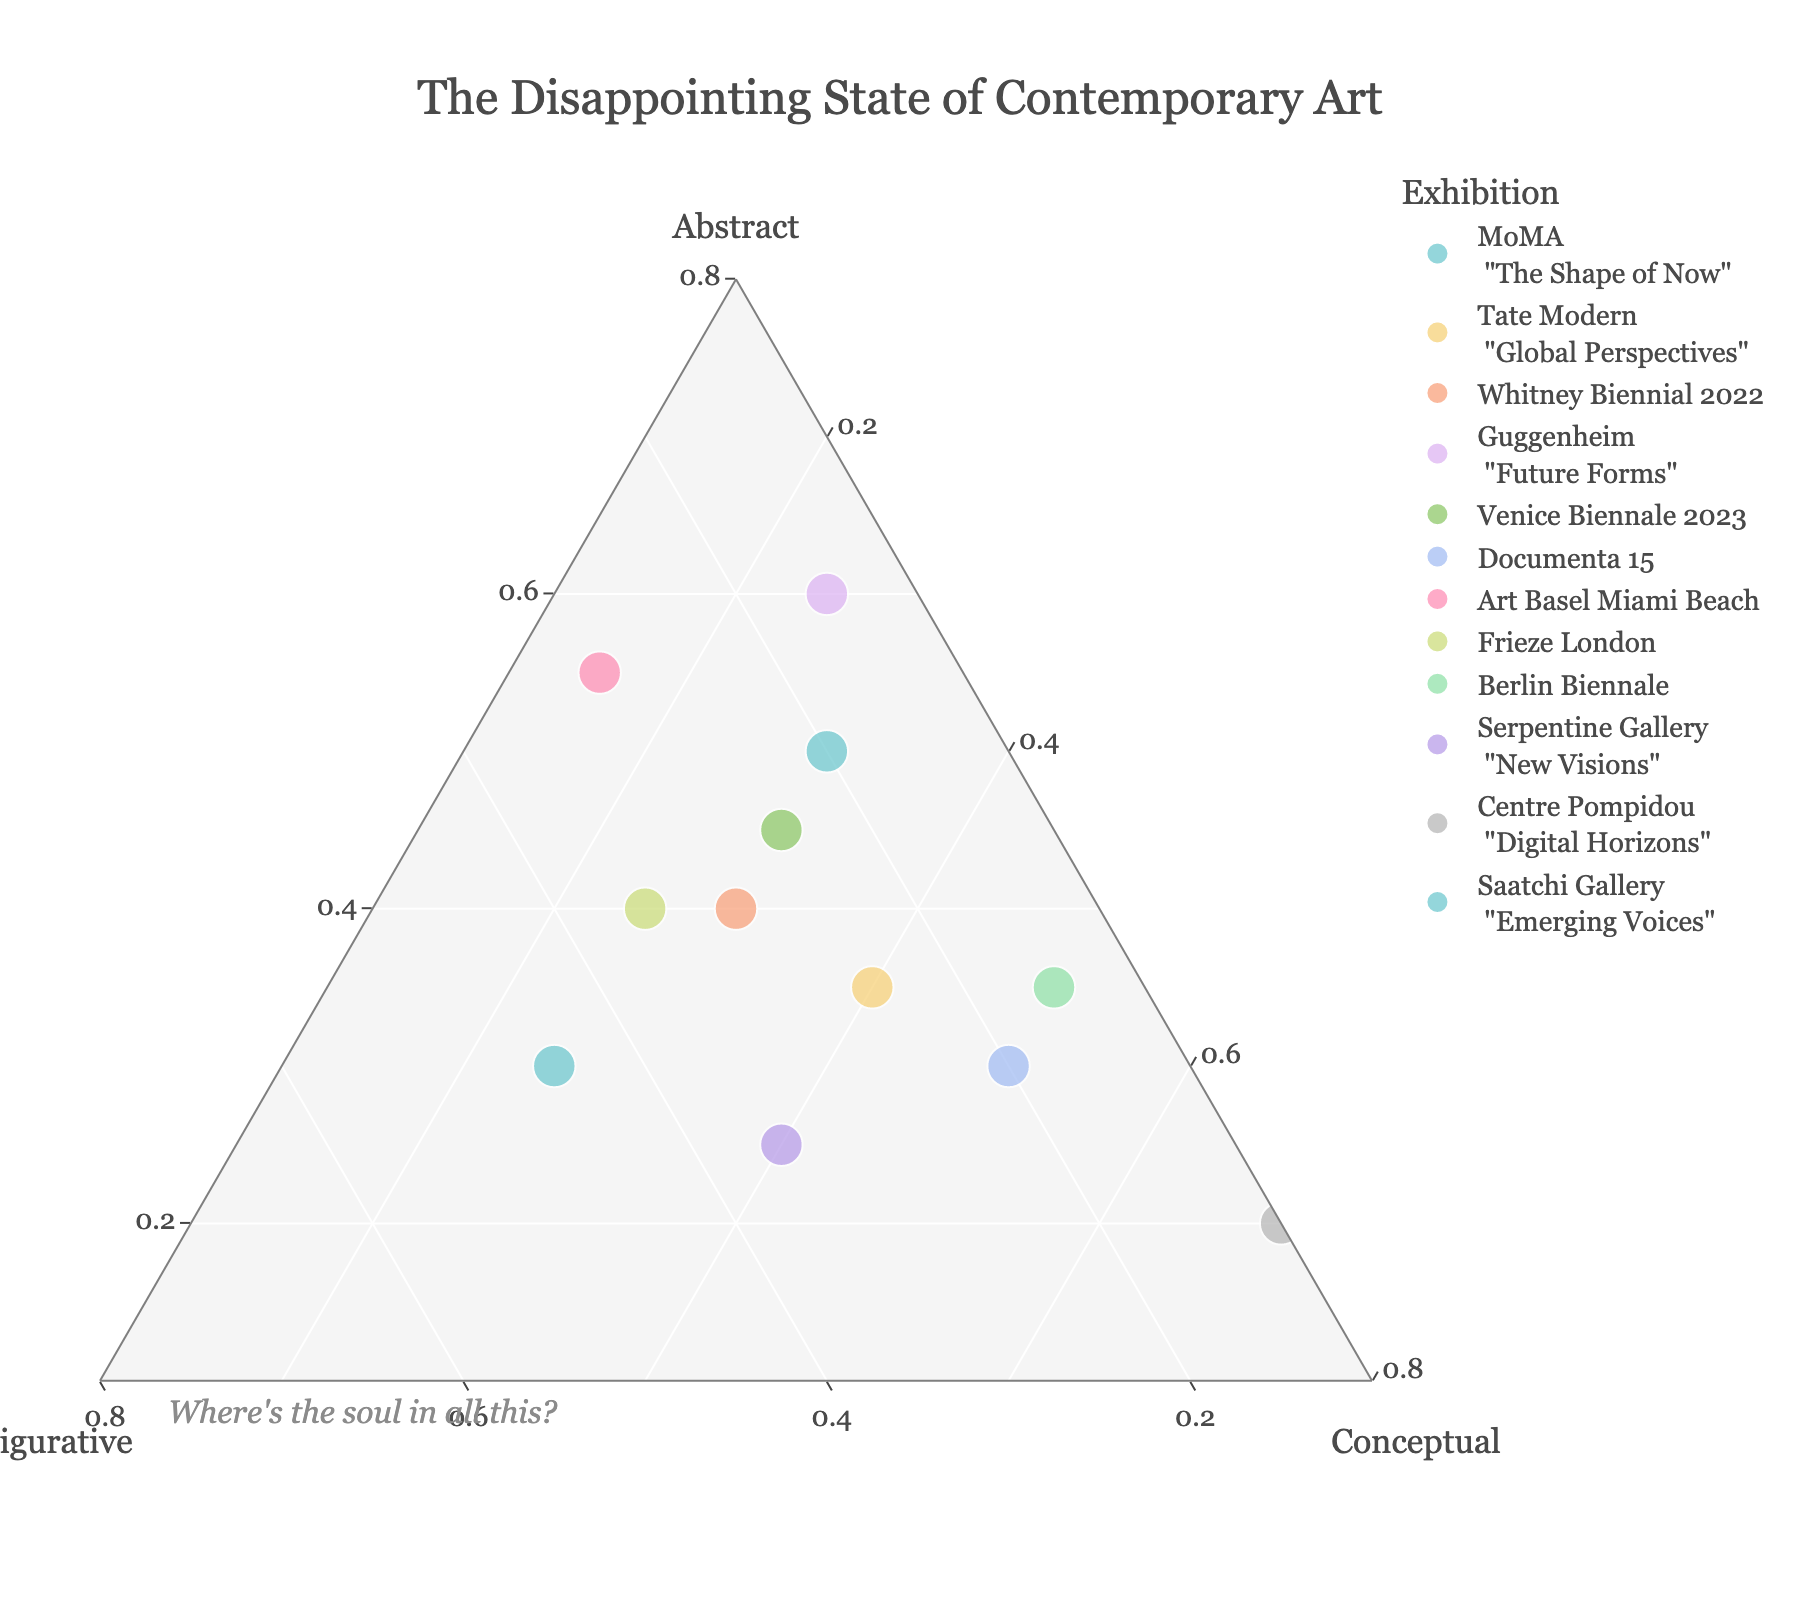What's the title of the figure? The title of the figure is positioned at the top of the plot and is often in a larger or bold font to distinguish it from other text.
Answer: The Disappointing State of Contemporary Art What are the three axes labeled in the figure? Ternary plots use three axes to represent three variables. These axis titles are typically positioned along the edges of the triangle.
Answer: Abstract, Figurative, Conceptual How many data points (exhibitions) are displayed in the figure? By counting the individual markers or points displayed within the ternary plot area, we can determine the total number of data points.
Answer: 12 Which exhibition has the highest percentage of conceptual art? To find this, you need to look at the markers located closest to the 'Conceptual' axis end within the ternary plot.
Answer: Centre Pompidou's <br> Digital Horizons Which exhibitions have an equal proportion of abstract and conceptual art? Identifying this requires finding points where the 'Abstract' and 'Conceptual' values are the same by checking their positions within the plot.
Answer: Venice Biennale 2023; Whitney Biennial 2022 What's the average percentage of abstract art across all exhibitions? Sum all the values of 'Abstract' percentages and divide by the number of exhibitions. Calculation: (50+35+40+60+45+30+55+40+35+25+20+30)/12 = 38.75
Answer: 38.75 In which exhibition is the figurative art the second highest, and what's its percentage? First find the maximum figurative art percentage and then identify the second highest from the remaining values within the ternary plot. The highest percentage is 45 (Saatchi Gallery's Emerging Voices) and the second highest is 35 (Frieze London).
Answer: Frieze London, 35 Which exhibition has the smallest amount of figurative art? Locate the marker closest to the 'Figurative' axis with the smallest value.
Answer: Centre Pompidou's <br> Digital Horizons Compare MoMA's "The Shape of Now" and Guggenheim's "Future Forms" in terms of conceptual art. Which has more? Look at the position of the points representing these exhibitions on the 'Conceptual' axis, then compare their values.
Answer: MoMA's "The Shape of Now" What's the primary type of art in Documenta 15? Identify the largest percentage among 'Abstract,' 'Figurative,' and 'Conceptual' for Documenta 15 by looking at its position on the ternary plot.
Answer: Conceptual 